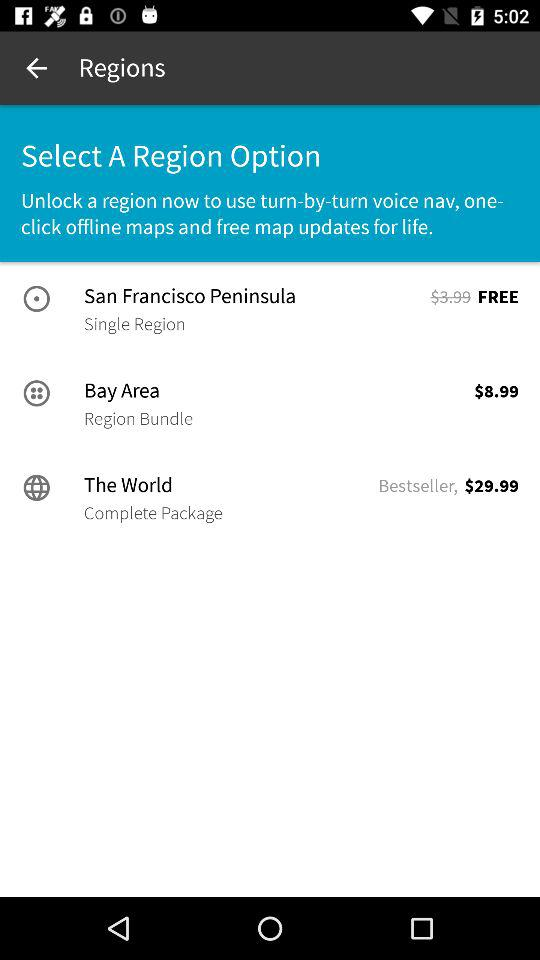How many regions are available?
Answer the question using a single word or phrase. 3 